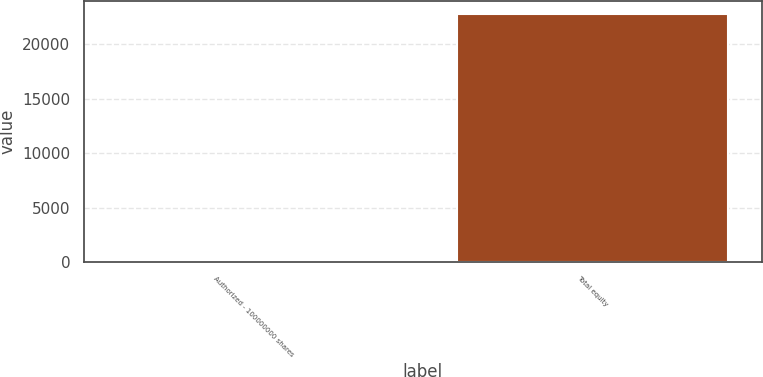<chart> <loc_0><loc_0><loc_500><loc_500><bar_chart><fcel>Authorized - 100000000 shares<fcel>Total equity<nl><fcel>3<fcel>22810<nl></chart> 